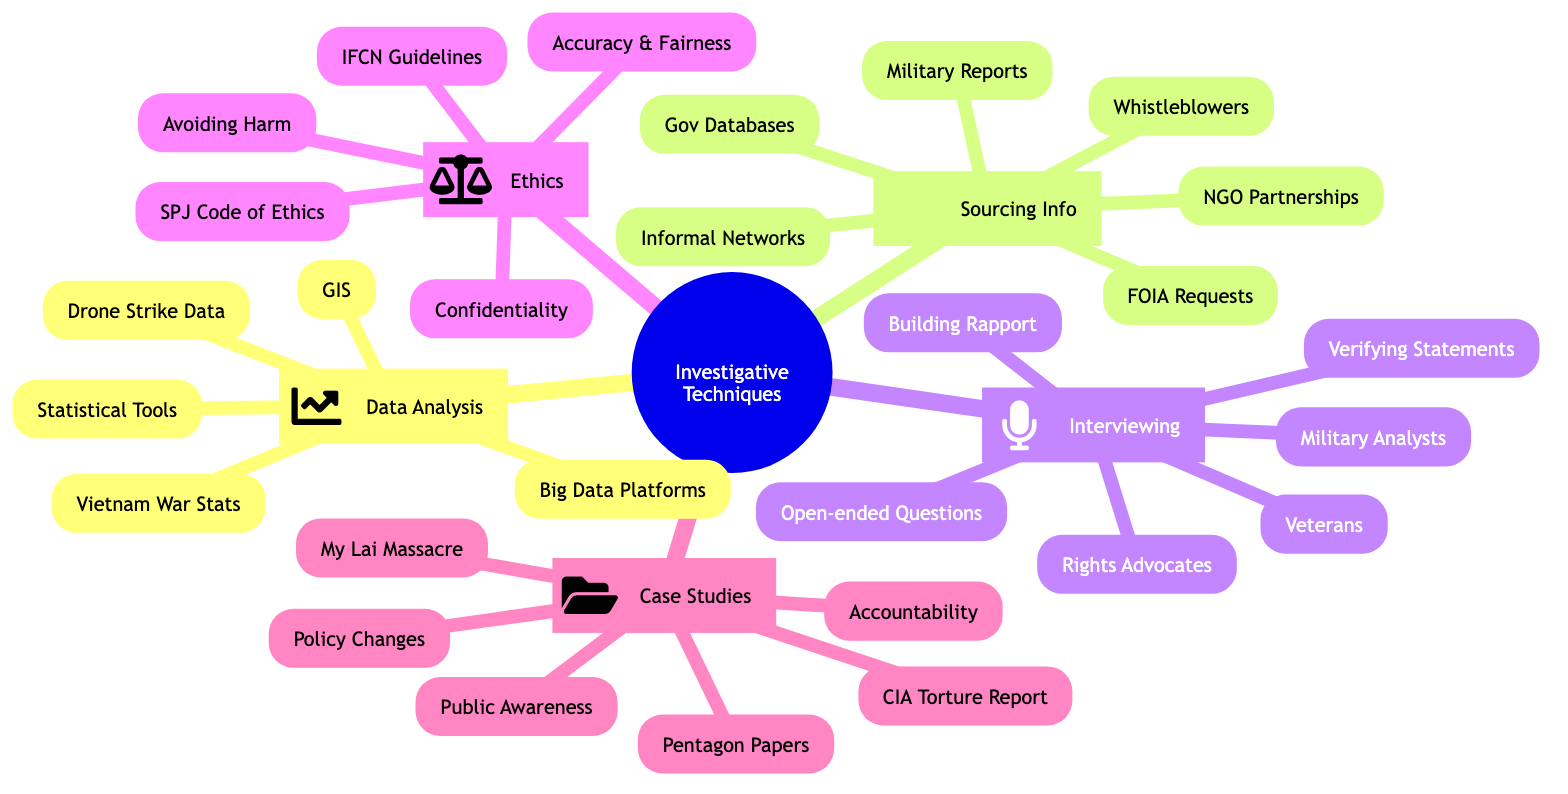What are the key components of Data Analysis? The main branches under Data Analysis in the diagram list three key components: Statistical Tools, Big Data Platforms, and Geographical Information Systems.
Answer: Statistical Tools, Big Data Platforms, Geographical Information Systems How many high-profile case examinations are mentioned? The diagram lists three specific case examinations under the High-profile Case Examinations branch: Pentagon Papers, My Lai Massacre, and CIA Torture Report. Thus, the total number is three.
Answer: 3 What is a principle listed under Ethical Considerations? The Ethical Considerations branch includes several principles, one of which is "Accuracy and Fairness." This means ensuring that reporting is precise and impartial.
Answer: Accuracy and Fairness Which interviewing technique is focused on relationship building? The diagram specifies "Building Rapport" as an interviewing technique, emphasizing the importance of establishing trust with interview subjects to facilitate open communication.
Answer: Building Rapport What databases are referenced under Sourcing Reliable Information? The resources listed under Sourcing Reliable Information include Public Records, which mention Government Databases, among others. This indicates these are sources for factual and useful information.
Answer: Government Databases How do past investigations impact public perception? The diagram illustrates that past investigations like the Pentagon Papers and My Lai Massacre lead to impacts such as Public Awareness, which reflects their role in shaping societal views and inciting discussions on military actions.
Answer: Public Awareness What is one of the open-ended questions used in interviewing? The interviewing techniques branch lists "Asking Open-ended Questions" to foster discussion, allowing interviewees to share more detailed responses rather than just yes/no answers.
Answer: Asking Open-ended Questions Name a partnership method mentioned under Sourcing Reliable Information. The diagram lists "Partnerships with NGOs" as one way to source reliable information, indicating collaboration as a method to gather data and insights.
Answer: Partnerships with NGOs What ethical guideline is mentioned in Ethical Considerations? The diagram references "Society of Professional Journalists Code of Ethics" as a guideline to ensure ethical journalistic practices are followed in investigative reporting.
Answer: Society of Professional Journalists Code of Ethics 